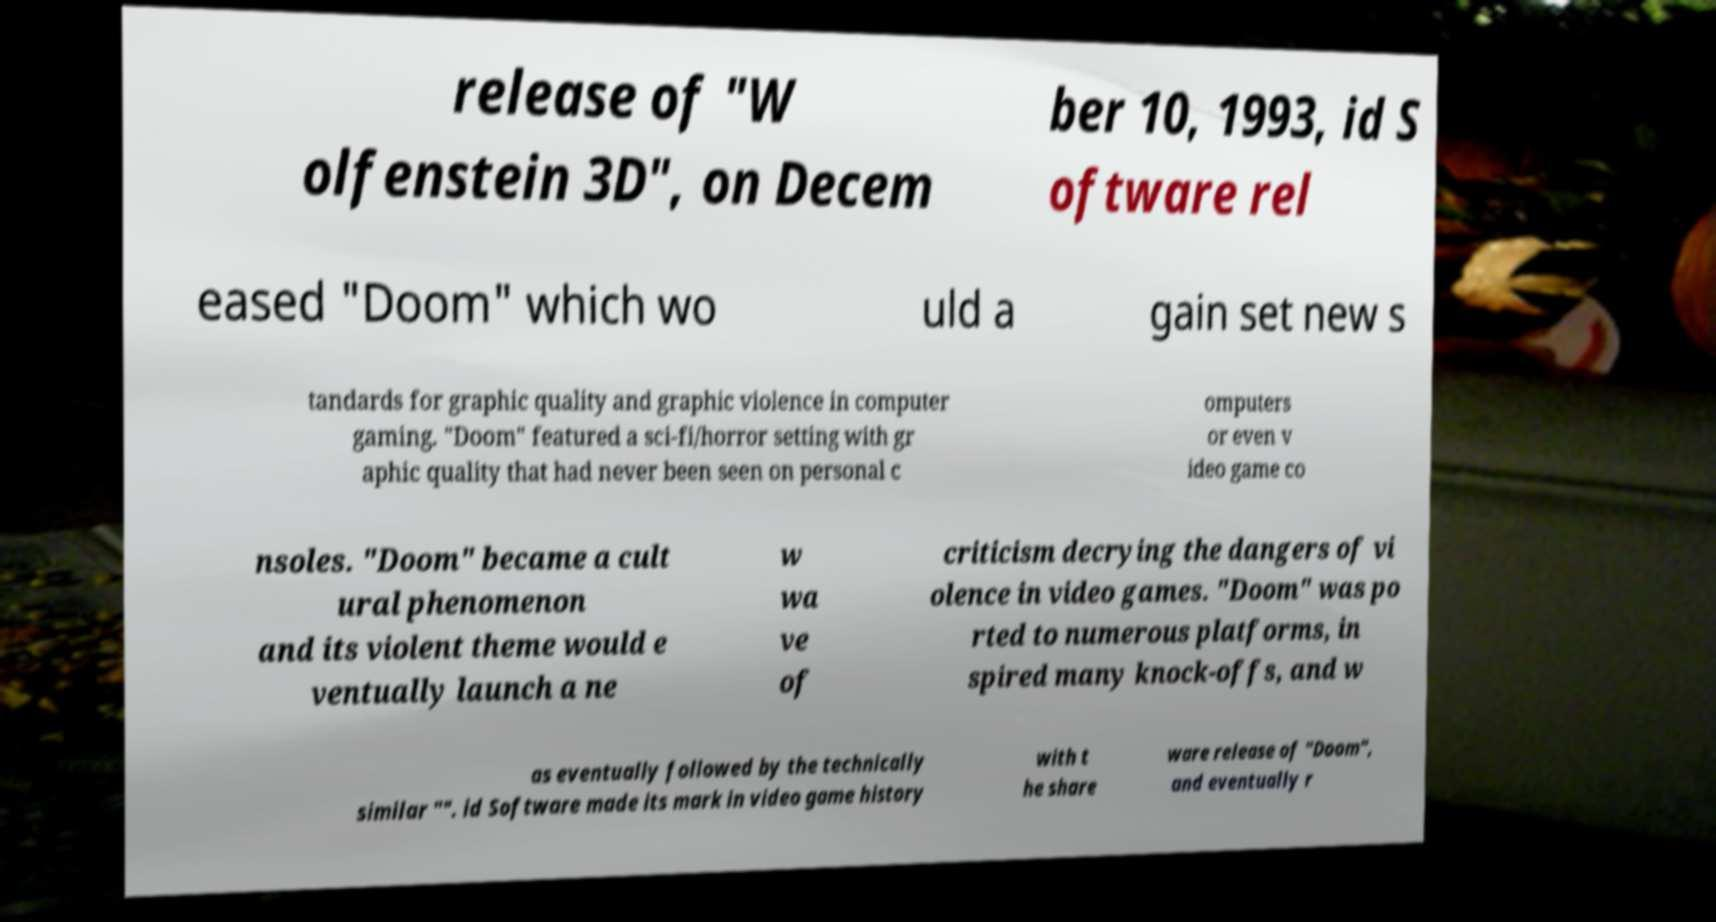Please identify and transcribe the text found in this image. release of "W olfenstein 3D", on Decem ber 10, 1993, id S oftware rel eased "Doom" which wo uld a gain set new s tandards for graphic quality and graphic violence in computer gaming. "Doom" featured a sci-fi/horror setting with gr aphic quality that had never been seen on personal c omputers or even v ideo game co nsoles. "Doom" became a cult ural phenomenon and its violent theme would e ventually launch a ne w wa ve of criticism decrying the dangers of vi olence in video games. "Doom" was po rted to numerous platforms, in spired many knock-offs, and w as eventually followed by the technically similar "". id Software made its mark in video game history with t he share ware release of "Doom", and eventually r 